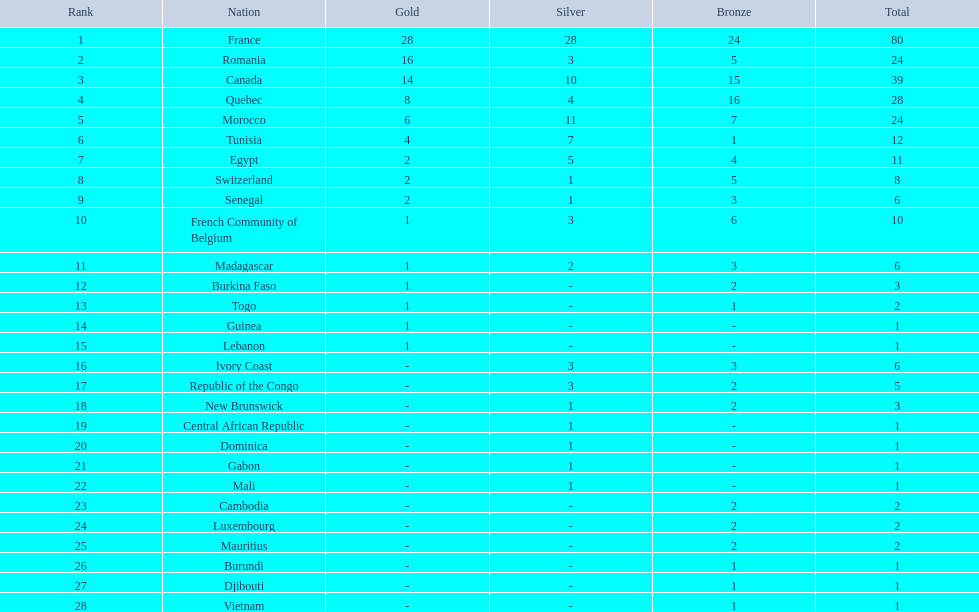What is the difference in the number of medals won by egypt compared to ivory coast? 5. 